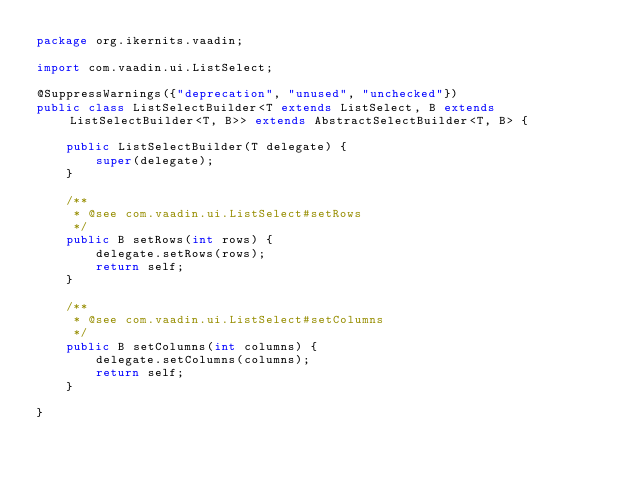Convert code to text. <code><loc_0><loc_0><loc_500><loc_500><_Java_>package org.ikernits.vaadin;

import com.vaadin.ui.ListSelect;

@SuppressWarnings({"deprecation", "unused", "unchecked"})
public class ListSelectBuilder<T extends ListSelect, B extends ListSelectBuilder<T, B>> extends AbstractSelectBuilder<T, B> {

    public ListSelectBuilder(T delegate) {
        super(delegate);
    }
    
    /**
     * @see com.vaadin.ui.ListSelect#setRows
     */
    public B setRows(int rows) {
        delegate.setRows(rows);
        return self;
    }
    
    /**
     * @see com.vaadin.ui.ListSelect#setColumns
     */
    public B setColumns(int columns) {
        delegate.setColumns(columns);
        return self;
    }
    
}
</code> 